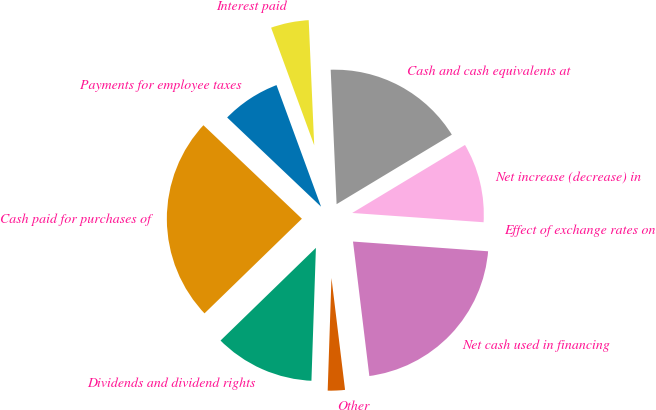Convert chart to OTSL. <chart><loc_0><loc_0><loc_500><loc_500><pie_chart><fcel>Payments for employee taxes<fcel>Cash paid for purchases of<fcel>Dividends and dividend rights<fcel>Other<fcel>Net cash used in financing<fcel>Effect of exchange rates on<fcel>Net increase (decrease) in<fcel>Cash and cash equivalents at<fcel>Interest paid<nl><fcel>7.32%<fcel>24.36%<fcel>12.19%<fcel>2.46%<fcel>21.93%<fcel>0.02%<fcel>9.76%<fcel>17.06%<fcel>4.89%<nl></chart> 